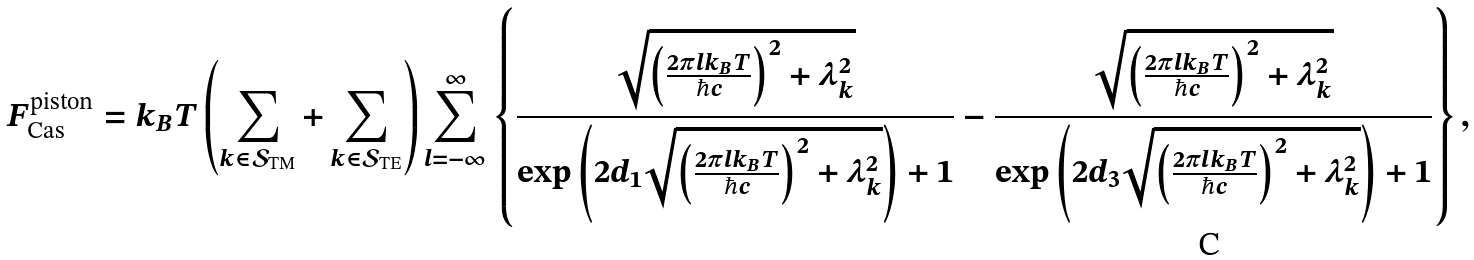Convert formula to latex. <formula><loc_0><loc_0><loc_500><loc_500>F _ { \text {Cas} } ^ { \text {piston} } = k _ { B } T \left ( \sum _ { k \in \mathcal { S } _ { \text {TM} } } + \sum _ { k \in \mathcal { S } _ { \text {TE} } } \right ) \sum _ { l = - \infty } ^ { \infty } \left \{ \frac { \sqrt { \left ( \frac { 2 \pi l k _ { B } T } { \hbar { c } } \right ) ^ { 2 } + \lambda _ { k } ^ { 2 } } } { \exp \left ( 2 d _ { 1 } \sqrt { \left ( \frac { 2 \pi l k _ { B } T } { \hbar { c } } \right ) ^ { 2 } + \lambda _ { k } ^ { 2 } } \right ) + 1 } - \frac { \sqrt { \left ( \frac { 2 \pi l k _ { B } T } { \hbar { c } } \right ) ^ { 2 } + \lambda _ { k } ^ { 2 } } } { \exp \left ( 2 d _ { 3 } \sqrt { \left ( \frac { 2 \pi l k _ { B } T } { \hbar { c } } \right ) ^ { 2 } + \lambda _ { k } ^ { 2 } } \right ) + 1 } \right \} ,</formula> 